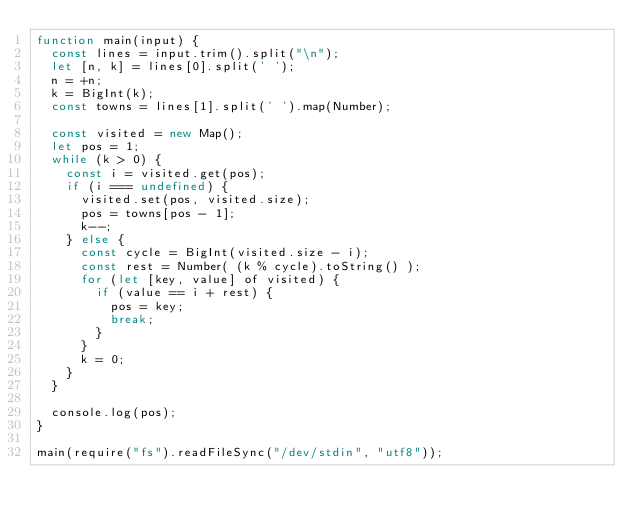<code> <loc_0><loc_0><loc_500><loc_500><_JavaScript_>function main(input) {
  const lines = input.trim().split("\n");
  let [n, k] = lines[0].split(' ');
  n = +n;
  k = BigInt(k);
  const towns = lines[1].split(' ').map(Number);

  const visited = new Map();
  let pos = 1;
  while (k > 0) {
    const i = visited.get(pos);
    if (i === undefined) {
      visited.set(pos, visited.size);
      pos = towns[pos - 1];
      k--;
    } else {
      const cycle = BigInt(visited.size - i);
      const rest = Number( (k % cycle).toString() );
      for (let [key, value] of visited) {
        if (value == i + rest) {
          pos = key;
          break;
        }
      }
      k = 0;
    }
  }
  
  console.log(pos);
}

main(require("fs").readFileSync("/dev/stdin", "utf8"));</code> 